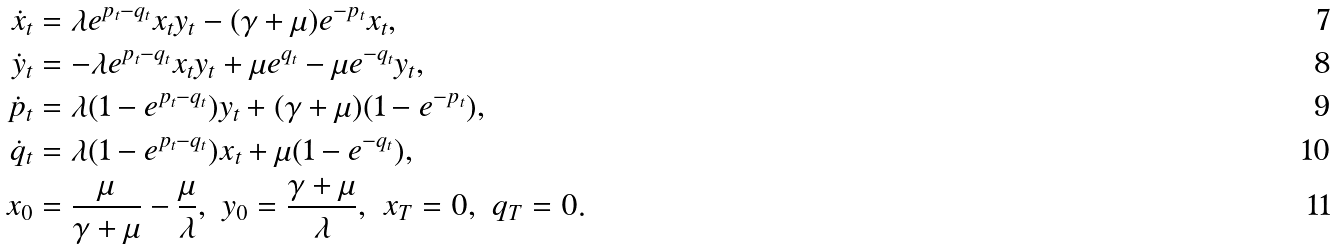<formula> <loc_0><loc_0><loc_500><loc_500>\dot { x } _ { t } & = \lambda e ^ { p _ { t } - q _ { t } } x _ { t } y _ { t } - ( \gamma + \mu ) e ^ { - p _ { t } } x _ { t } , \\ \dot { y } _ { t } & = - \lambda e ^ { p _ { t } - q _ { t } } x _ { t } y _ { t } + \mu e ^ { q _ { t } } - \mu e ^ { - q _ { t } } y _ { t } , \\ \dot { p } _ { t } & = \lambda ( 1 - e ^ { p _ { t } - q _ { t } } ) y _ { t } + ( \gamma + \mu ) ( 1 - e ^ { - p _ { t } } ) , \\ \dot { q } _ { t } & = \lambda ( 1 - e ^ { p _ { t } - q _ { t } } ) x _ { t } + \mu ( 1 - e ^ { - q _ { t } } ) , \\ x _ { 0 } & = \frac { \mu } { \gamma + \mu } - \frac { \mu } { \lambda } , \ y _ { 0 } = \frac { \gamma + \mu } { \lambda } , \ x _ { T } = 0 , \ q _ { T } = 0 .</formula> 